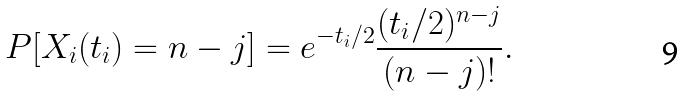Convert formula to latex. <formula><loc_0><loc_0><loc_500><loc_500>P [ X _ { i } ( t _ { i } ) = n - j ] = e ^ { - t _ { i } / 2 } \frac { ( t _ { i } / 2 ) ^ { n - j } } { ( n - j ) ! } .</formula> 